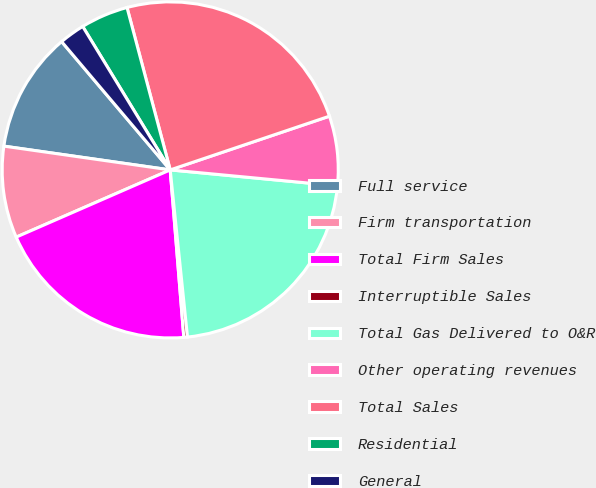Convert chart to OTSL. <chart><loc_0><loc_0><loc_500><loc_500><pie_chart><fcel>Full service<fcel>Firm transportation<fcel>Total Firm Sales<fcel>Interruptible Sales<fcel>Total Gas Delivered to O&R<fcel>Other operating revenues<fcel>Total Sales<fcel>Residential<fcel>General<nl><fcel>11.56%<fcel>8.81%<fcel>19.74%<fcel>0.35%<fcel>21.85%<fcel>6.69%<fcel>23.96%<fcel>4.58%<fcel>2.46%<nl></chart> 